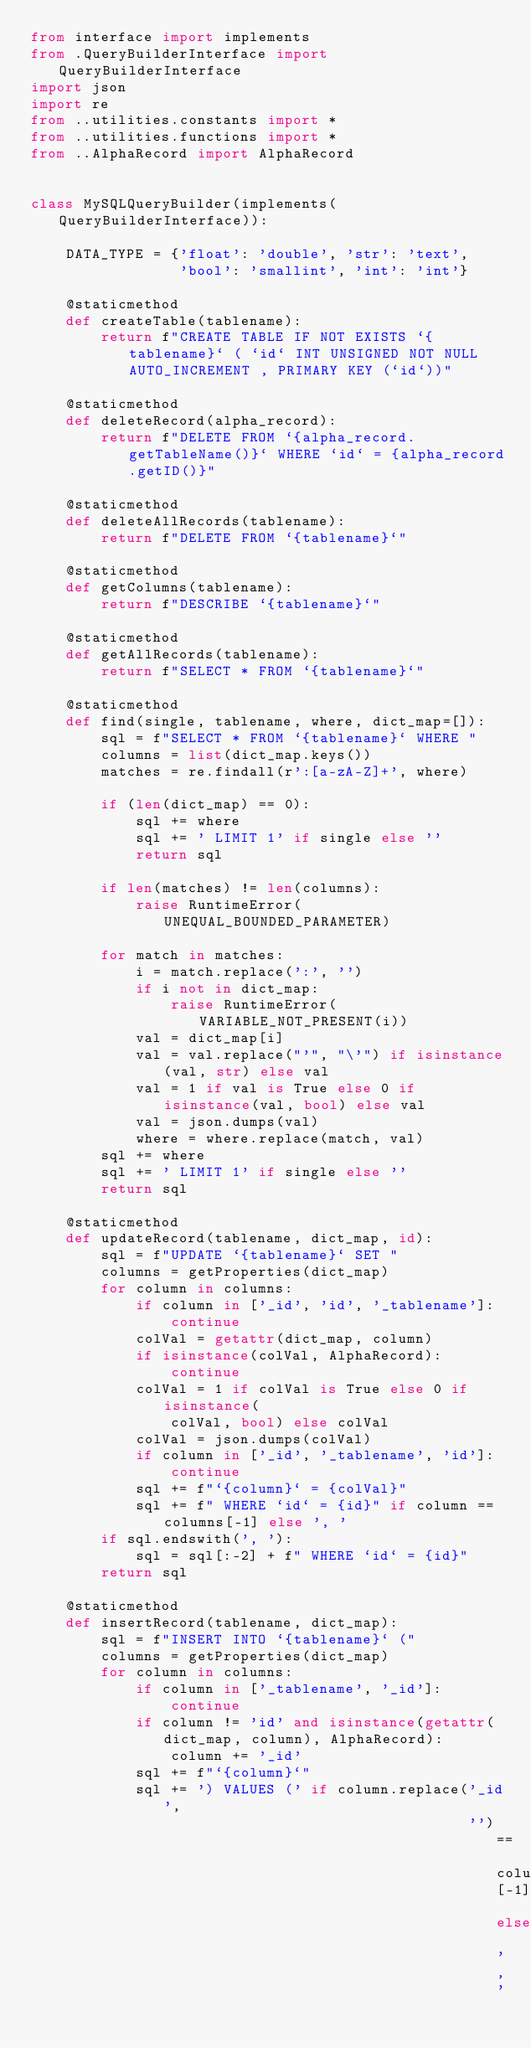Convert code to text. <code><loc_0><loc_0><loc_500><loc_500><_Python_>from interface import implements
from .QueryBuilderInterface import QueryBuilderInterface
import json
import re
from ..utilities.constants import *
from ..utilities.functions import *
from ..AlphaRecord import AlphaRecord


class MySQLQueryBuilder(implements(QueryBuilderInterface)):

    DATA_TYPE = {'float': 'double', 'str': 'text',
                 'bool': 'smallint', 'int': 'int'}

    @staticmethod
    def createTable(tablename):
        return f"CREATE TABLE IF NOT EXISTS `{tablename}` ( `id` INT UNSIGNED NOT NULL AUTO_INCREMENT , PRIMARY KEY (`id`))"

    @staticmethod
    def deleteRecord(alpha_record):
        return f"DELETE FROM `{alpha_record.getTableName()}` WHERE `id` = {alpha_record.getID()}"

    @staticmethod
    def deleteAllRecords(tablename):
        return f"DELETE FROM `{tablename}`"

    @staticmethod
    def getColumns(tablename):
        return f"DESCRIBE `{tablename}`"

    @staticmethod
    def getAllRecords(tablename):
        return f"SELECT * FROM `{tablename}`"

    @staticmethod
    def find(single, tablename, where, dict_map=[]):
        sql = f"SELECT * FROM `{tablename}` WHERE "
        columns = list(dict_map.keys())
        matches = re.findall(r':[a-zA-Z]+', where)

        if (len(dict_map) == 0):
            sql += where
            sql += ' LIMIT 1' if single else ''
            return sql

        if len(matches) != len(columns):
            raise RuntimeError(UNEQUAL_BOUNDED_PARAMETER)

        for match in matches:
            i = match.replace(':', '')
            if i not in dict_map:
                raise RuntimeError(VARIABLE_NOT_PRESENT(i))
            val = dict_map[i]
            val = val.replace("'", "\'") if isinstance(val, str) else val
            val = 1 if val is True else 0 if isinstance(val, bool) else val
            val = json.dumps(val)
            where = where.replace(match, val)
        sql += where
        sql += ' LIMIT 1' if single else ''
        return sql

    @staticmethod
    def updateRecord(tablename, dict_map, id):
        sql = f"UPDATE `{tablename}` SET "
        columns = getProperties(dict_map)
        for column in columns:
            if column in ['_id', 'id', '_tablename']:
                continue
            colVal = getattr(dict_map, column)
            if isinstance(colVal, AlphaRecord):
                continue
            colVal = 1 if colVal is True else 0 if isinstance(
                colVal, bool) else colVal
            colVal = json.dumps(colVal)
            if column in ['_id', '_tablename', 'id']:
                continue
            sql += f"`{column}` = {colVal}"
            sql += f" WHERE `id` = {id}" if column == columns[-1] else ', '
        if sql.endswith(', '):
            sql = sql[:-2] + f" WHERE `id` = {id}"
        return sql

    @staticmethod
    def insertRecord(tablename, dict_map):
        sql = f"INSERT INTO `{tablename}` ("
        columns = getProperties(dict_map)
        for column in columns:
            if column in ['_tablename', '_id']:
                continue
            if column != 'id' and isinstance(getattr(dict_map, column), AlphaRecord):
                column += '_id'
            sql += f"`{column}`"
            sql += ') VALUES (' if column.replace('_id',
                                                  '') == columns[-1] else ','</code> 